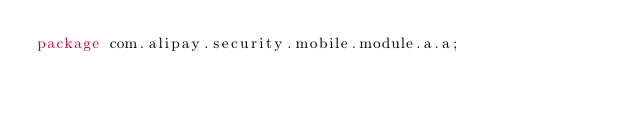<code> <loc_0><loc_0><loc_500><loc_500><_Java_>package com.alipay.security.mobile.module.a.a;
</code> 